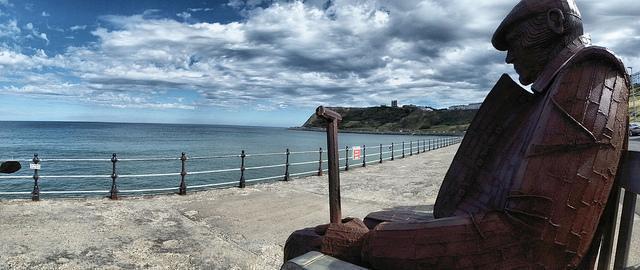What is this man doing?
Make your selection from the four choices given to correctly answer the question.
Options: Is resting, is surfing, watching movie, driving bike. Is resting. 